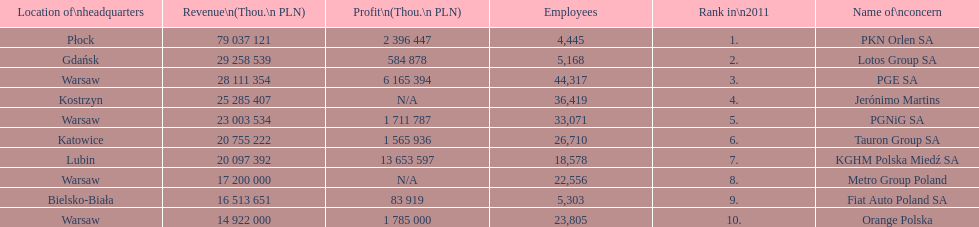Which company had the most employees? PGE SA. 